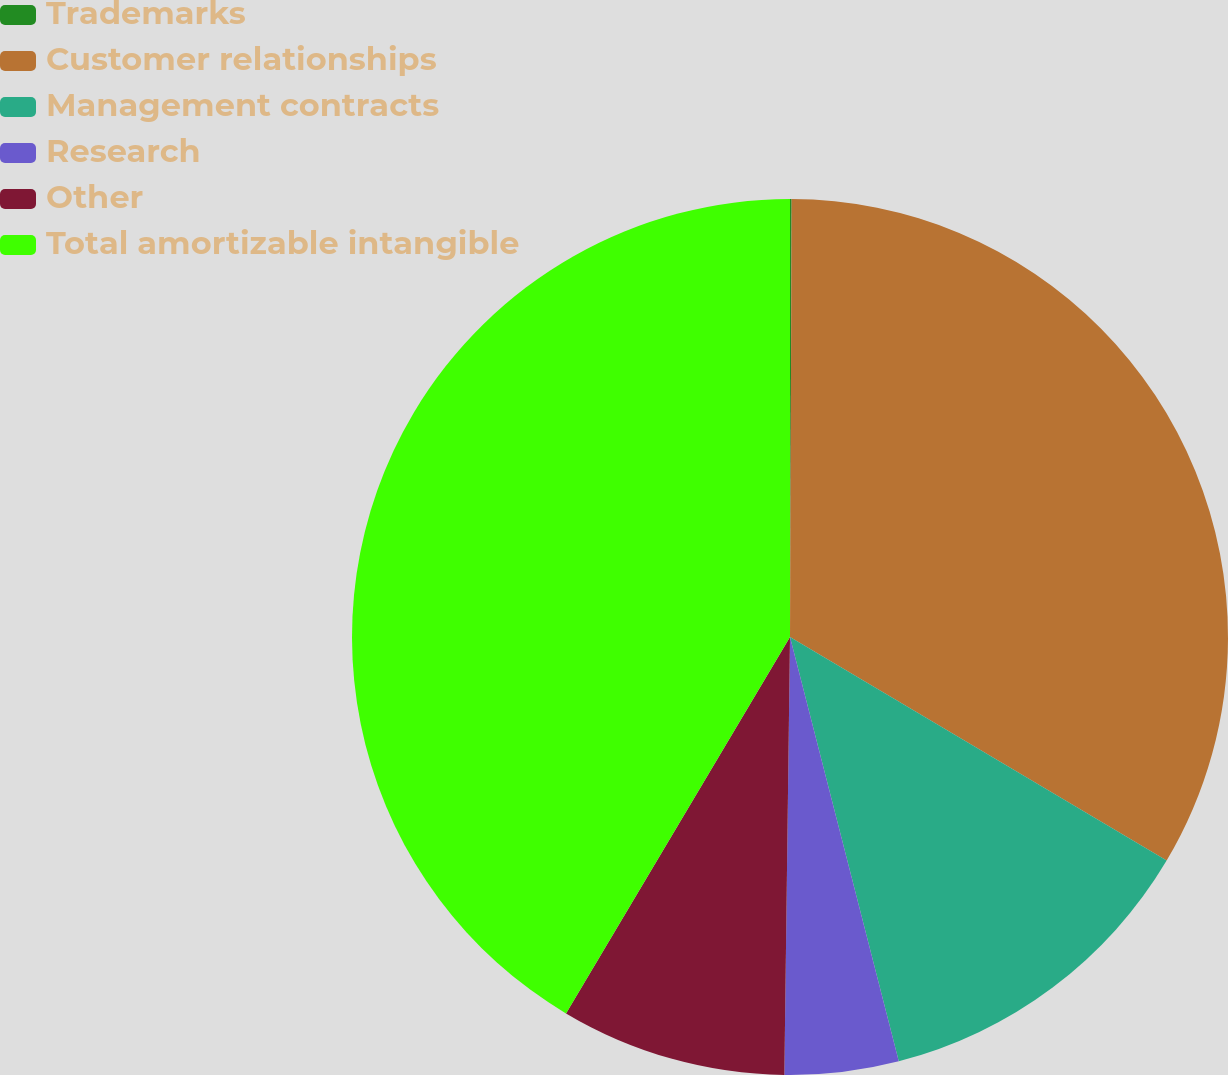Convert chart to OTSL. <chart><loc_0><loc_0><loc_500><loc_500><pie_chart><fcel>Trademarks<fcel>Customer relationships<fcel>Management contracts<fcel>Research<fcel>Other<fcel>Total amortizable intangible<nl><fcel>0.06%<fcel>33.47%<fcel>12.48%<fcel>4.2%<fcel>8.34%<fcel>41.46%<nl></chart> 